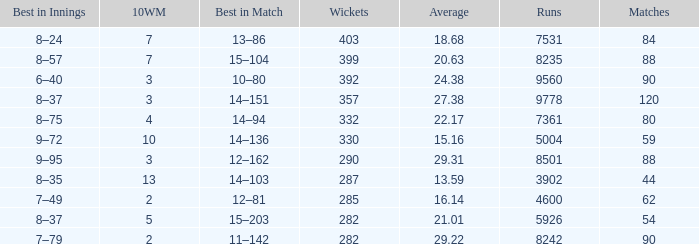How many wickets have runs under 7531, matches over 44, and an average of 22.17? 332.0. 